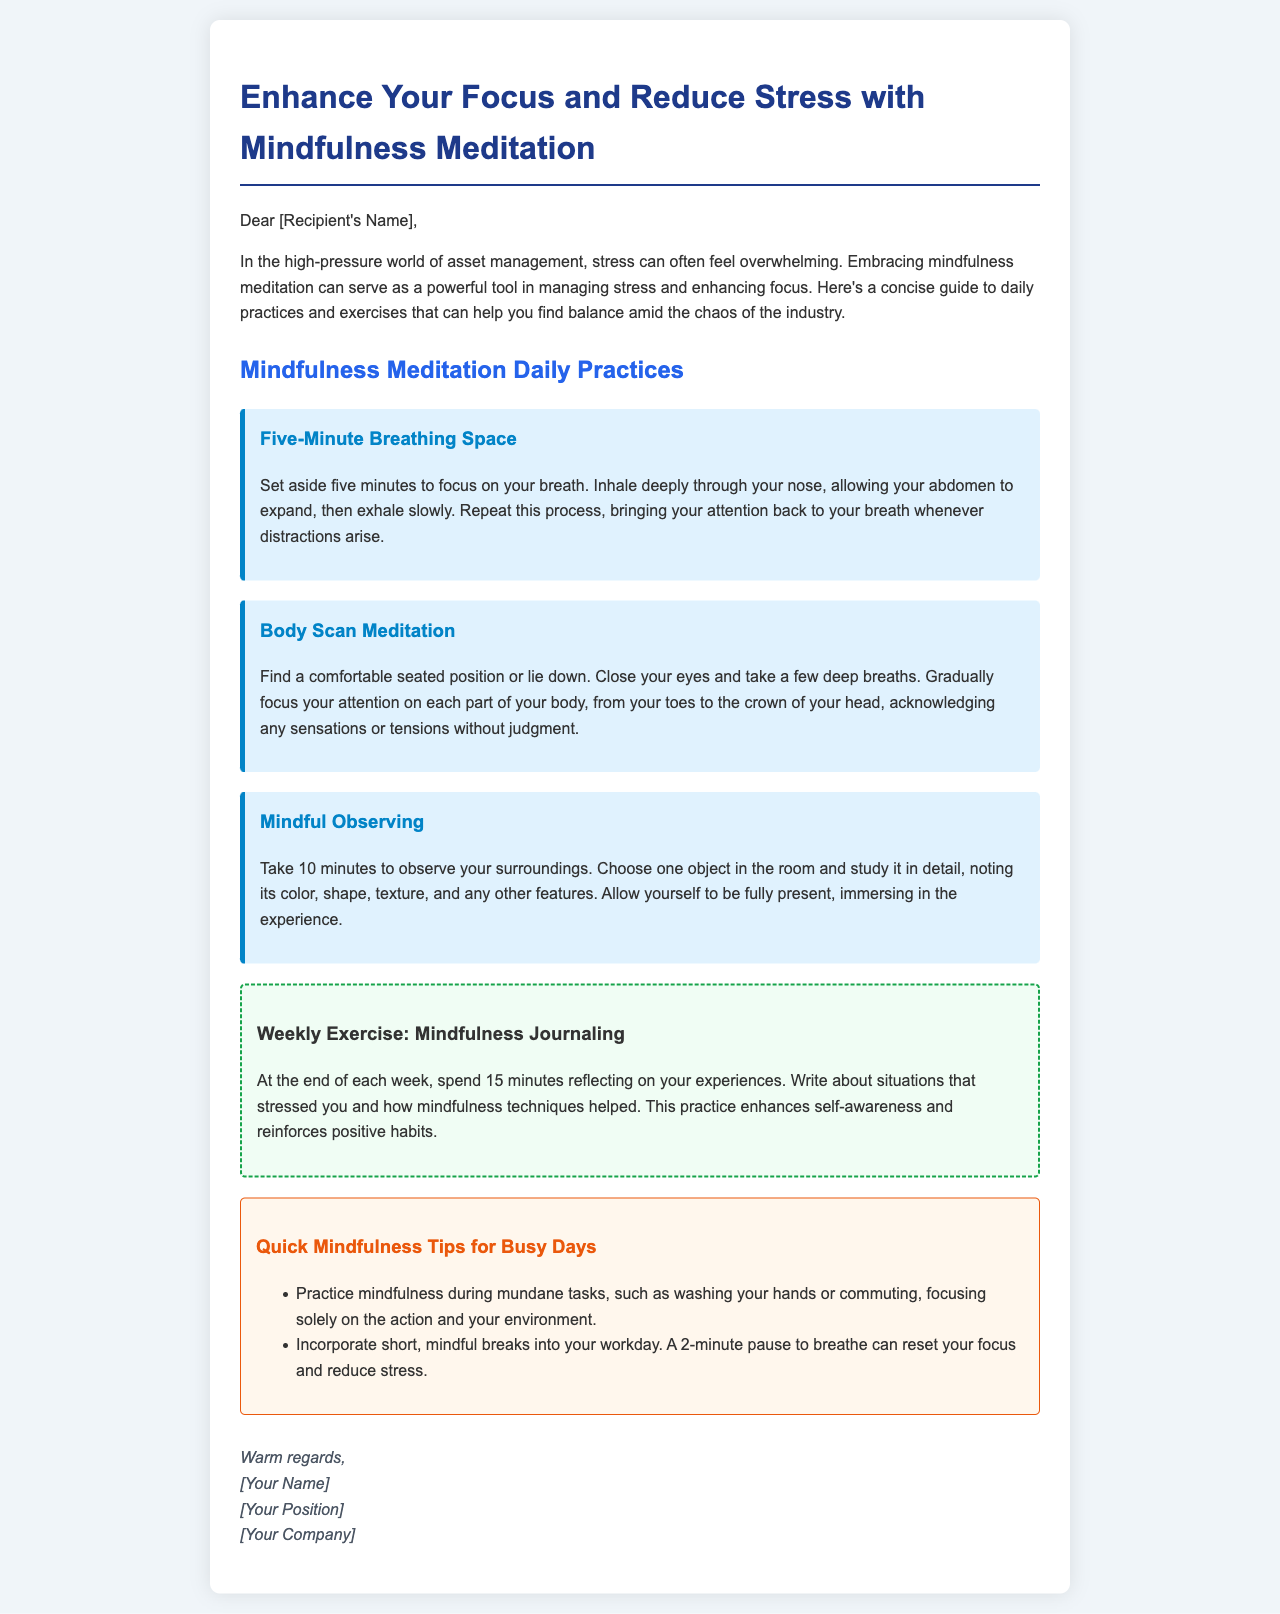What is the title of the document? The title is prominently displayed at the top of the document, indicating the main topic covered.
Answer: Enhance Your Focus and Reduce Stress with Mindfulness Meditation How long should the Five-Minute Breathing Space practice last? The document specifies a duration for the practice, which is crucial for effective time management.
Answer: Five minutes What is the weekly exercise mentioned in the document? The weekly exercise is designed to reinforce mindfulness practices, making it essential for ongoing application.
Answer: Mindfulness Journaling What is the color of the "Quick Mindfulness Tips for Busy Days" section? The color distinction helps to categorize information, making it easier to find specific advice.
Answer: #fff7ed (or light orange) What should you focus on during the Body Scan Meditation? This practice has a specific focus that helps practitioners reconnect with their bodies, which is vital in mindfulness.
Answer: Each part of your body 